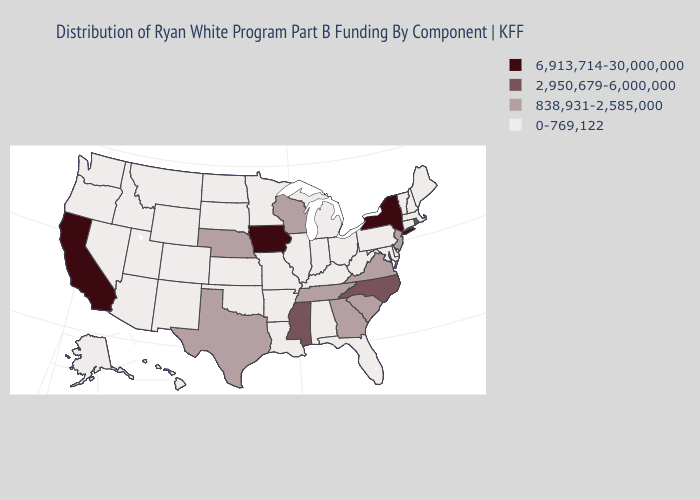Name the states that have a value in the range 838,931-2,585,000?
Be succinct. Georgia, Nebraska, New Jersey, South Carolina, Tennessee, Texas, Virginia, Wisconsin. Does Wyoming have a lower value than Montana?
Give a very brief answer. No. Among the states that border South Dakota , does Wyoming have the lowest value?
Write a very short answer. Yes. Name the states that have a value in the range 838,931-2,585,000?
Be succinct. Georgia, Nebraska, New Jersey, South Carolina, Tennessee, Texas, Virginia, Wisconsin. Does the map have missing data?
Give a very brief answer. No. What is the value of Washington?
Short answer required. 0-769,122. What is the highest value in states that border Missouri?
Give a very brief answer. 6,913,714-30,000,000. What is the lowest value in the USA?
Short answer required. 0-769,122. Does New York have the highest value in the Northeast?
Keep it brief. Yes. What is the lowest value in states that border Pennsylvania?
Write a very short answer. 0-769,122. Among the states that border Wisconsin , which have the lowest value?
Short answer required. Illinois, Michigan, Minnesota. Does the map have missing data?
Short answer required. No. What is the lowest value in the USA?
Quick response, please. 0-769,122. Name the states that have a value in the range 2,950,679-6,000,000?
Concise answer only. Mississippi, North Carolina, Rhode Island. Does Missouri have the lowest value in the USA?
Answer briefly. Yes. 